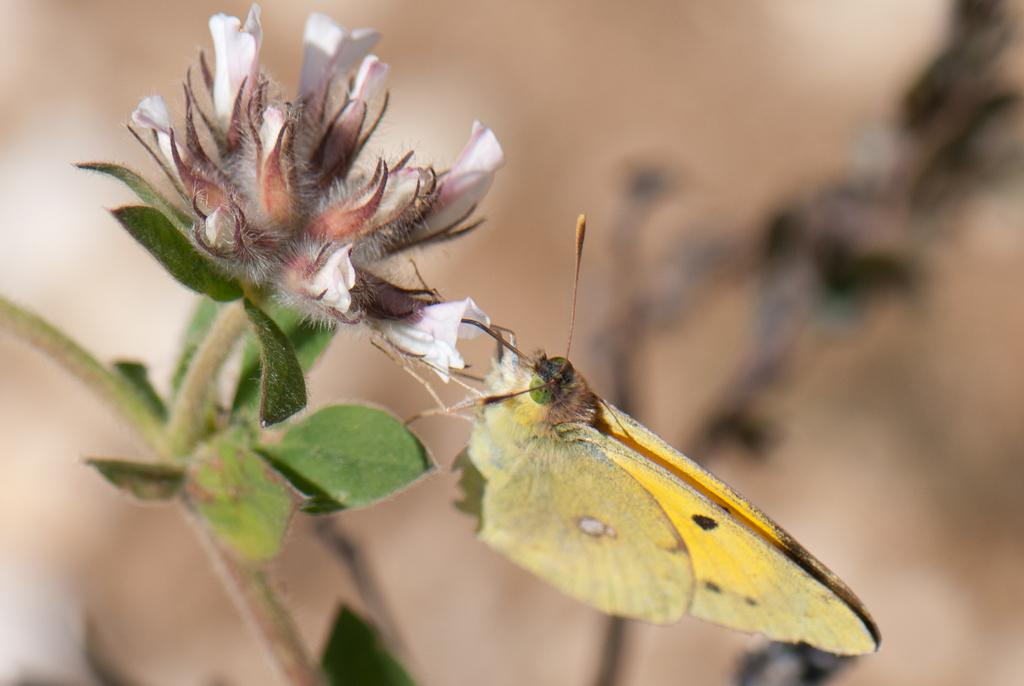What is the main subject of the image? There is a butterfly in the image. Where is the butterfly located? The butterfly is on a flower. What else can be seen in the image besides the butterfly? Leaves are present in the image. What type of guide is the butterfly holding in the image? There is no guide present in the image, as butterflies do not hold or use guides. 